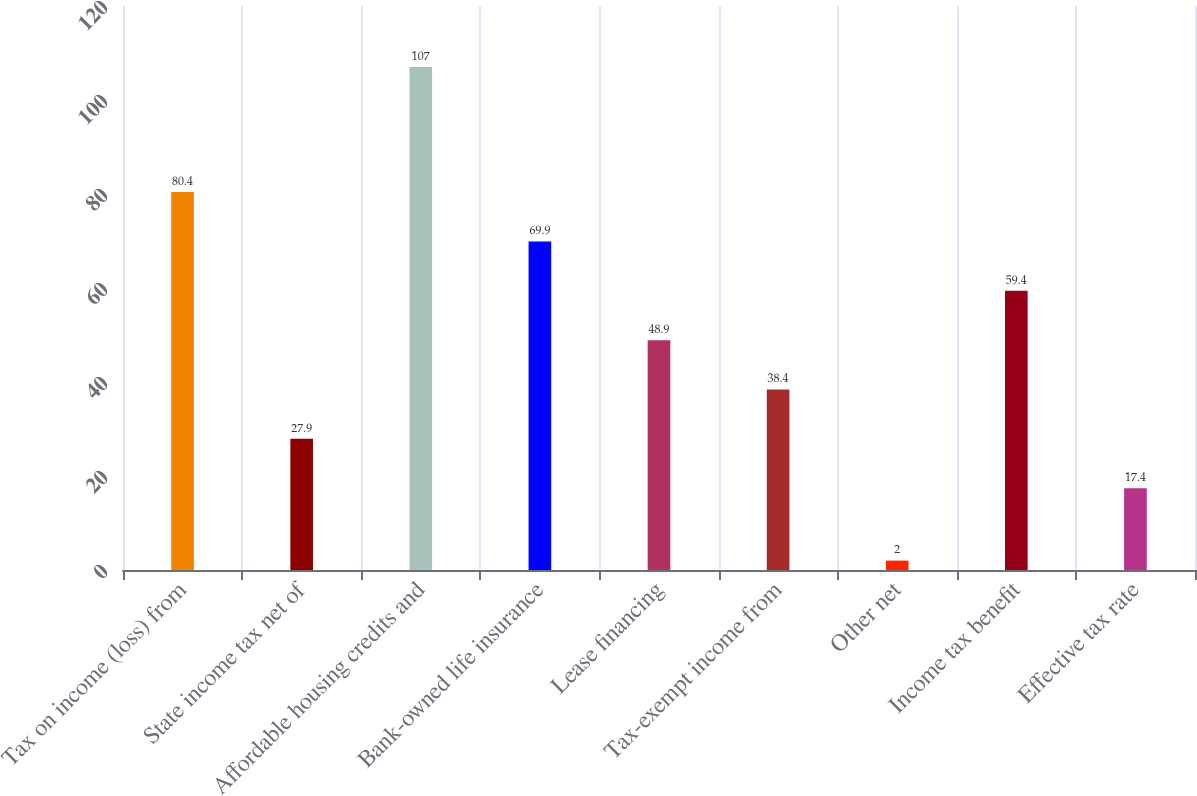Convert chart to OTSL. <chart><loc_0><loc_0><loc_500><loc_500><bar_chart><fcel>Tax on income (loss) from<fcel>State income tax net of<fcel>Affordable housing credits and<fcel>Bank-owned life insurance<fcel>Lease financing<fcel>Tax-exempt income from<fcel>Other net<fcel>Income tax benefit<fcel>Effective tax rate<nl><fcel>80.4<fcel>27.9<fcel>107<fcel>69.9<fcel>48.9<fcel>38.4<fcel>2<fcel>59.4<fcel>17.4<nl></chart> 